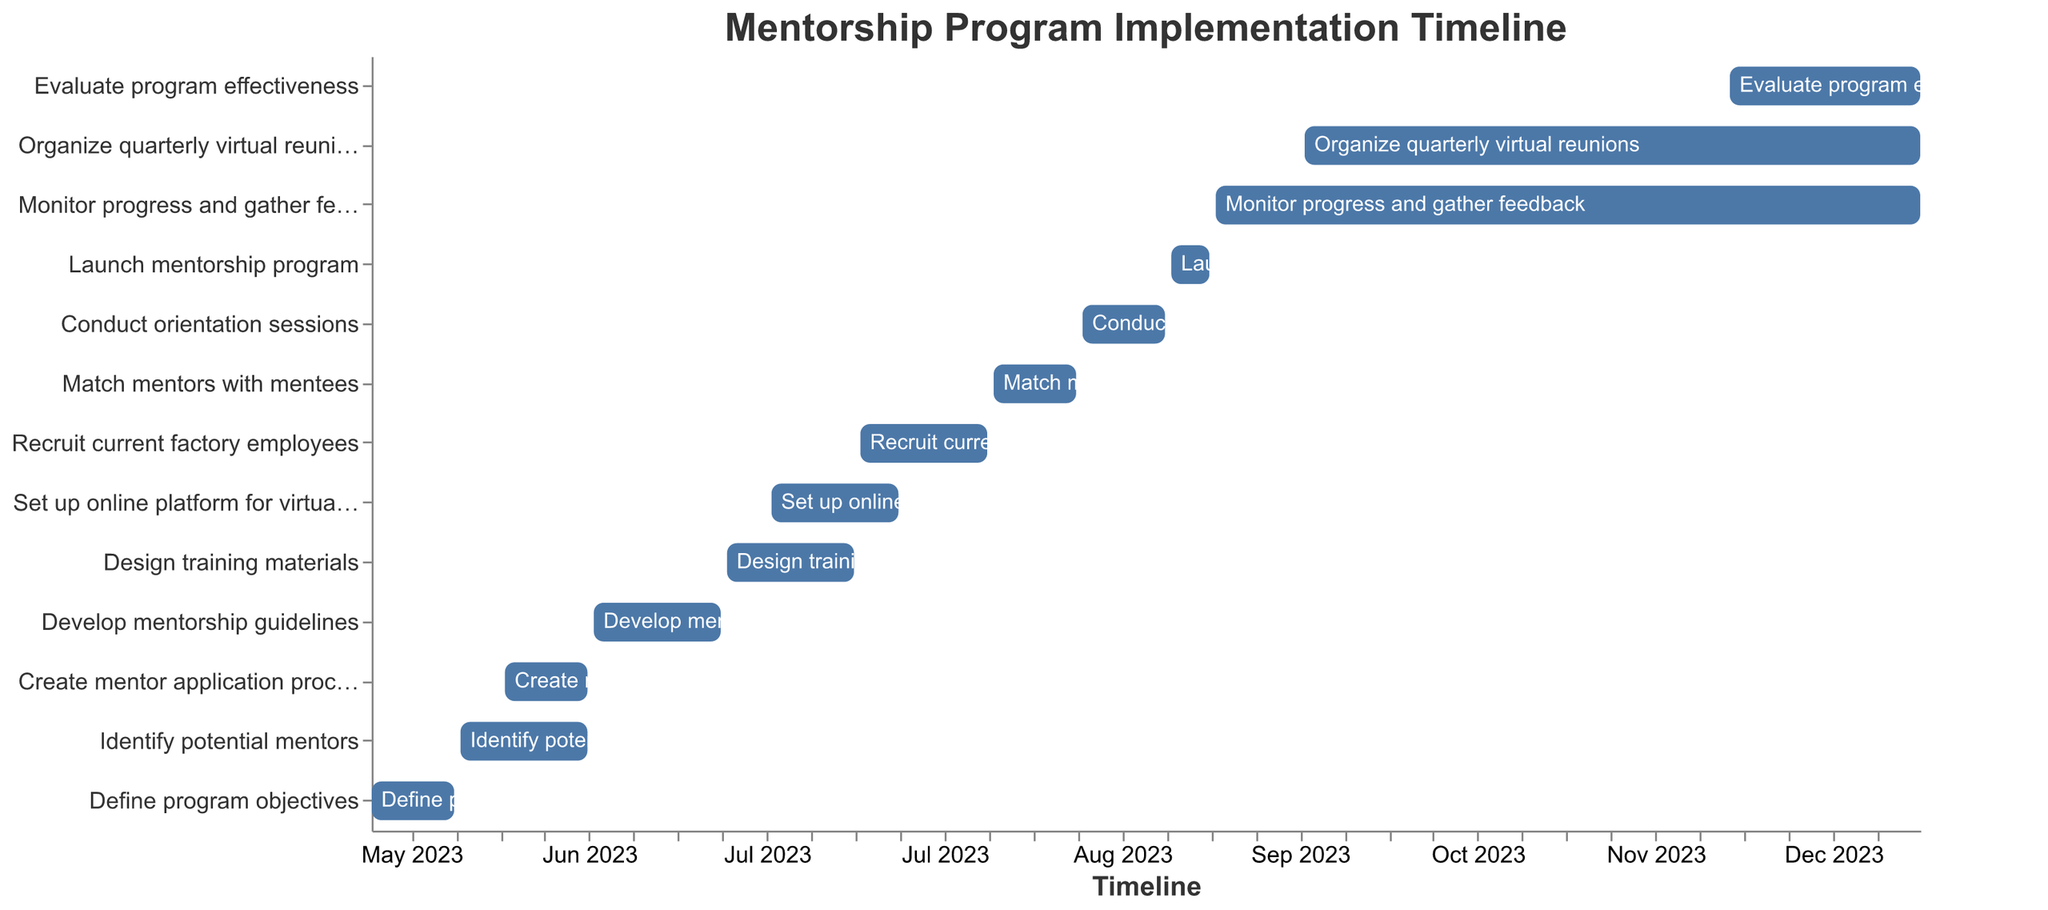What is the duration of the "Design training materials" task? The duration of the "Design training materials" task can be found directly in the figure. It spans from June 26, 2023, to July 16, 2023, which is a total of 21 days.
Answer: 21 days Which task has the shortest duration, and how long is it? To find the task with the shortest duration, we need to compare all task durations. The "Launch mentorship program" task lasts for 7 days, which is the shortest duration in the figure.
Answer: Launch mentorship program, 7 days Which task overlaps with "Set up online platform for virtual meetings" and what are their corresponding start and end dates? To identify tasks that overlap with "Set up online platform for virtual meetings" (July 3, 2023, to July 23, 2023), we need to find tasks that have start or end dates within this range. "Design training materials" (June 26, 2023, to July 16, 2023) overlaps with it.
Answer: Design training materials, June 26, 2023 to July 16, 2023 Which tasks are still ongoing after the "Launch mentorship program" is completed? The "Launch mentorship program" ends on September 10, 2023. Tasks starting after this date include "Monitor progress and gather feedback" (September 11, 2023), "Organize quarterly virtual reunions" (September 25, 2023), and "Evaluate program effectiveness" (December 1, 2023).
Answer: Monitor progress and gather feedback, Organize quarterly virtual reunions, Evaluate program effectiveness How long is the gap between the end of "Identify potential mentors" and the start of "Develop mentorship guidelines"? "Identify potential mentors" ends on June 4, 2023, and "Develop mentorship guidelines" starts on June 5, 2023. There is no gap between these tasks, as they are consecutive.
Answer: No gap What is the chronological order of the first three tasks in the implementation timeline? To determine the chronological order, we check the start dates of all tasks. The first three tasks by start date are "Define program objectives" (May 1, 2023), "Identify potential mentors" (May 15, 2023), and "Create mentor application process" (May 22, 2023).
Answer: Define program objectives, Identify potential mentors, Create mentor application process Which task has the longest duration, and how many days does it span? The task with the longest duration in the figure is "Monitor progress and gather feedback," lasting from September 11, 2023, to December 31, 2023, for a total of 112 days.
Answer: Monitor progress and gather feedback, 112 days When does the "Recruit current factory employees" task start and end? The "Recruit current factory employees" task starts on July 17, 2023, and ends on August 6, 2023, as shown in the figure.
Answer: July 17, 2023, to August 6, 2023 What is the total duration of tasks starting in September 2023? Tasks starting in September 2023 are "Launch mentorship program" (7 days), "Monitor progress and gather feedback" (112 days), and "Organize quarterly virtual reunions" (98 days). Adding these durations gives 7 + 112 + 98 = 217 days.
Answer: 217 days 